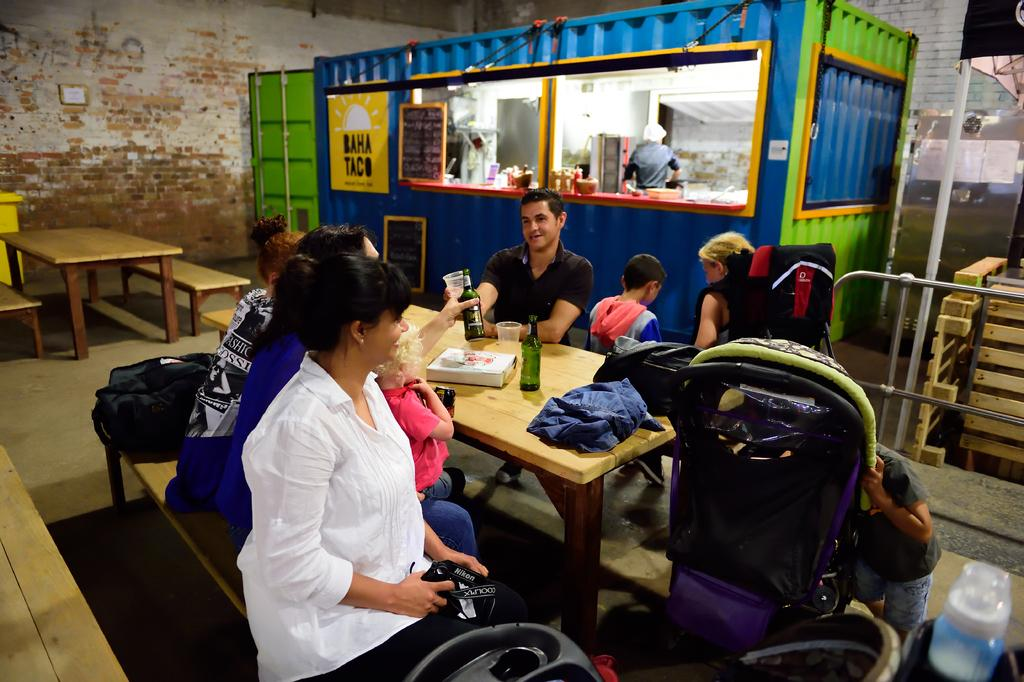What are the people in the image doing? The people in the image are sitting. How many tables can be seen in the image? There are two tables in the image. What is on one of the tables? There are items on one of the tables. What can be seen in the background of the image? There is a wall and a shop in the background of the image. Is there anyone inside the shop? Yes, there is a person inside the shop. What type of yoke is being used by the mice in the image? There are no mice or yokes present in the image. What kind of drug is the person in the shop selling in the image? There is no indication of any drug-related activity in the image. 